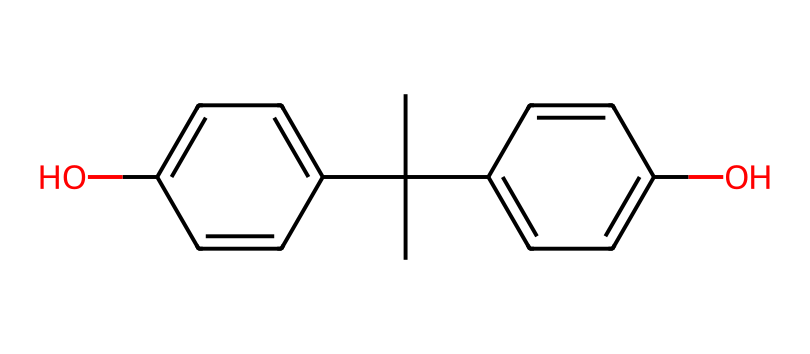What is the IUPAC name of this chemical? The chemical represented has two phenolic hydroxyl groups (aromatic with -OH attached) and two isopropyl groups connected to a central carbon. Therefore, its IUPAC name is 2,2-bis(4-hydroxyphenyl)propane.
Answer: 2,2-bis(4-hydroxyphenyl)propane How many carbon atoms are in the structure? By analyzing the SMILES representation, there are 15 carbon atoms in total, including those from the isopropyl groups and the two phenolic rings.
Answer: 15 How many hydroxyl (–OH) groups are present? The structure contains two aromatic rings, each with one hydroxyl group attached, making a total of two hydroxyl groups in the molecule.
Answer: 2 What type of chemical compound is this? This compound is classified as a phenol because it contains hydroxyl (-OH) groups bonded directly to aromatic rings.
Answer: phenol Is the compound likely to be soluble in water? Phenolic compounds with multiple hydroxyl groups generally exhibit some solubility in water due to hydrogen bonding, suggesting that this compound, with two hydroxyls, is somewhat soluble.
Answer: somewhat soluble What functional groups are present in the structure? Upon examining the structure, we can identify the hydroxyl (–OH) group as the functional group, characteristic of phenols, and also the isopropyl groups, contributing to its overall structure.
Answer: hydroxyl group 